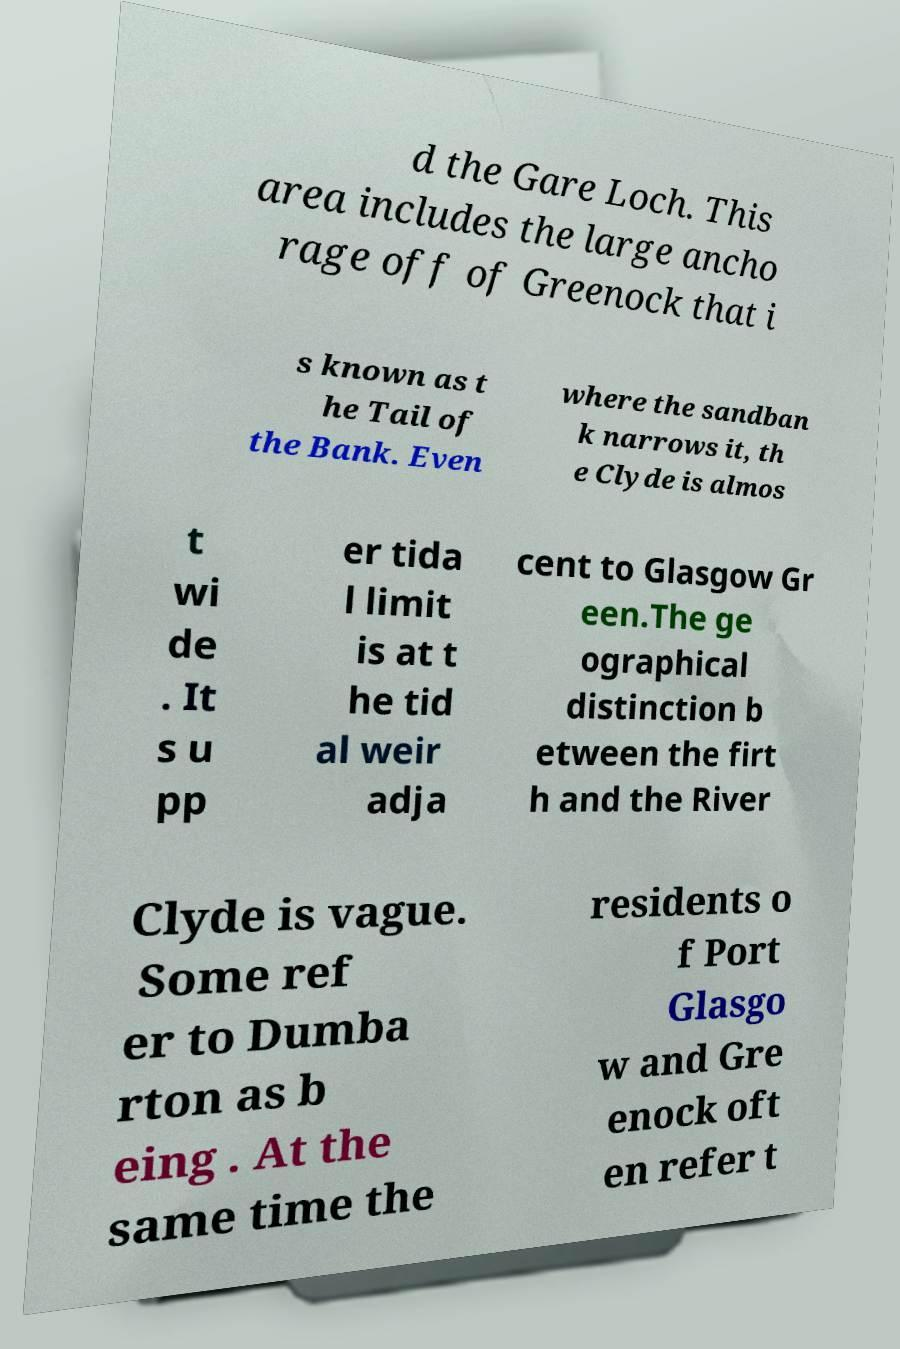Please identify and transcribe the text found in this image. d the Gare Loch. This area includes the large ancho rage off of Greenock that i s known as t he Tail of the Bank. Even where the sandban k narrows it, th e Clyde is almos t wi de . It s u pp er tida l limit is at t he tid al weir adja cent to Glasgow Gr een.The ge ographical distinction b etween the firt h and the River Clyde is vague. Some ref er to Dumba rton as b eing . At the same time the residents o f Port Glasgo w and Gre enock oft en refer t 